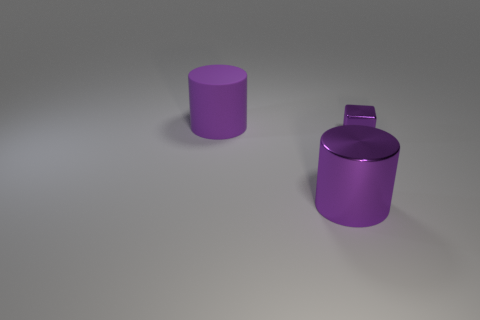Add 2 large objects. How many objects exist? 5 Subtract 1 cubes. How many cubes are left? 0 Subtract all cylinders. How many objects are left? 1 Subtract all brown cubes. Subtract all brown cylinders. How many cubes are left? 1 Subtract all large objects. Subtract all brown metallic things. How many objects are left? 1 Add 2 purple things. How many purple things are left? 5 Add 3 red metallic spheres. How many red metallic spheres exist? 3 Subtract 0 brown cylinders. How many objects are left? 3 